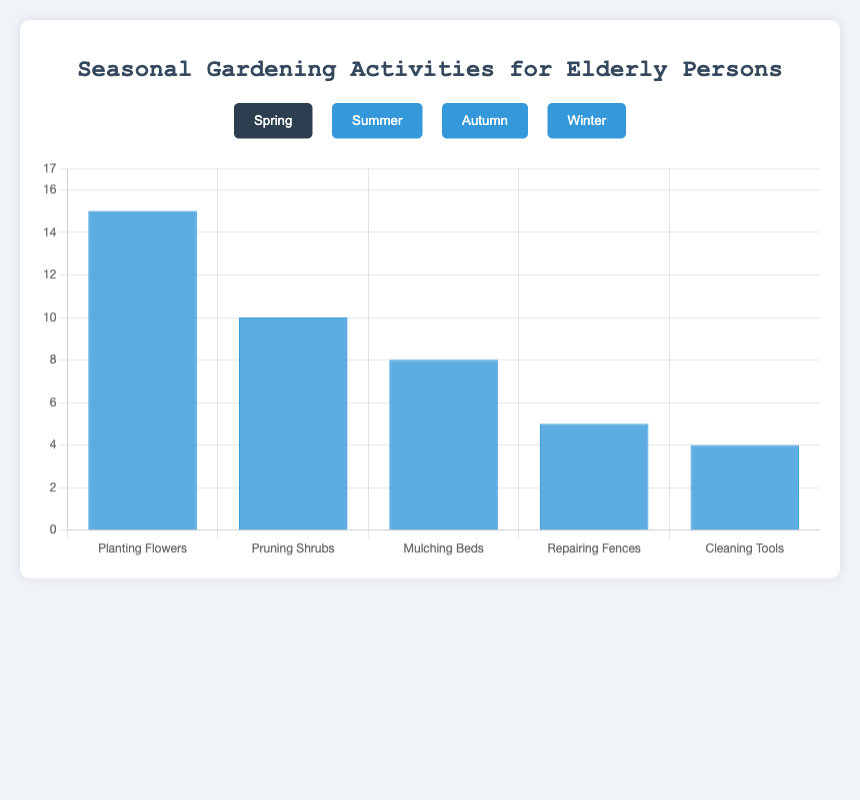Which season has the highest number of gardening activities? To find the season with the highest number of gardening activities, we compare the activity counts across all seasons. During summer, the "Watering Plants" activity peaks at 18, which is higher than any other activity in other seasons.
Answer: Summer Which gardening activity is done more frequently in Autumn compared to Winter? In Autumn, the most frequent activity is "Raking Leaves" with 14 counts. In Winter, "Planning Garden Layout" tops the list with 12 counts. Since 14 is greater than 12, "Raking Leaves" in Autumn is more frequent than "Planning Garden Layout" in Winter.
Answer: Raking Leaves What is the least common gardening activity in Spring? To determine the least common activity, we look at the Spring activities and their counts: "Planting Flowers" (15), "Pruning Shrubs" (10), "Mulching Beds" (8), "Repairing Fences" (5), and "Cleaning Tools" (4). The lowest count is for "Cleaning Tools" with 4.
Answer: Cleaning Tools How many more people engage in "Watering Plants" during summer compared to "Weeding"? "Watering Plants" has 18 counts, and "Weeding" has 12. The difference is calculated by subtracting 12 from 18. Hence, 18 - 12 = 6.
Answer: 6 Which activity has an equal frequency in both Spring and Autumn? We compare the activities and their counts. "Pruning Shrubs" in Spring is 10 and "Composting" in Autumn is also 10. Both these activities share the same frequency.
Answer: None What is the total number of gardening activities conducted in Winter? We add up all the Winter activities: "Planning Garden Layout" (12), "Inspecting Plant Pots" (8), "Organizing Wooden Crates" (7), "Repairing Greenhouse" (5), and "Ordering Seeds" (4). The sum is 12 + 8 + 7 + 5 + 4 = 36.
Answer: 36 Which activity sees a higher frequency in Summer compared to its counterpart in Autumn? Comparing the highest frequencies, in Summer "Watering Plants" (18) outnumbers Autumn's "Raking Leaves" (14). Hence, "Watering Plants" in Summer is more frequent than any Autumn activity.
Answer: Watering Plants What is the average number of people participating in Spring's gardening activities? Averaging the Spring activities: "Planting Flowers" (15), "Pruning Shrubs" (10), "Mulching Beds" (8), "Repairing Fences" (5), and "Cleaning Tools" (4). Sum is 15 + 10 + 8 + 5 + 4 = 42, and there are 5 activities. So, the average is 42 / 5 = 8.4.
Answer: 8.4 What's the sum of the frequencies of the top two gardening activities in Autumn? The top two activities in Autumn are "Raking Leaves" (14) and "Composting" (10). Their combined frequency is 14 + 10 = 24.
Answer: 24 